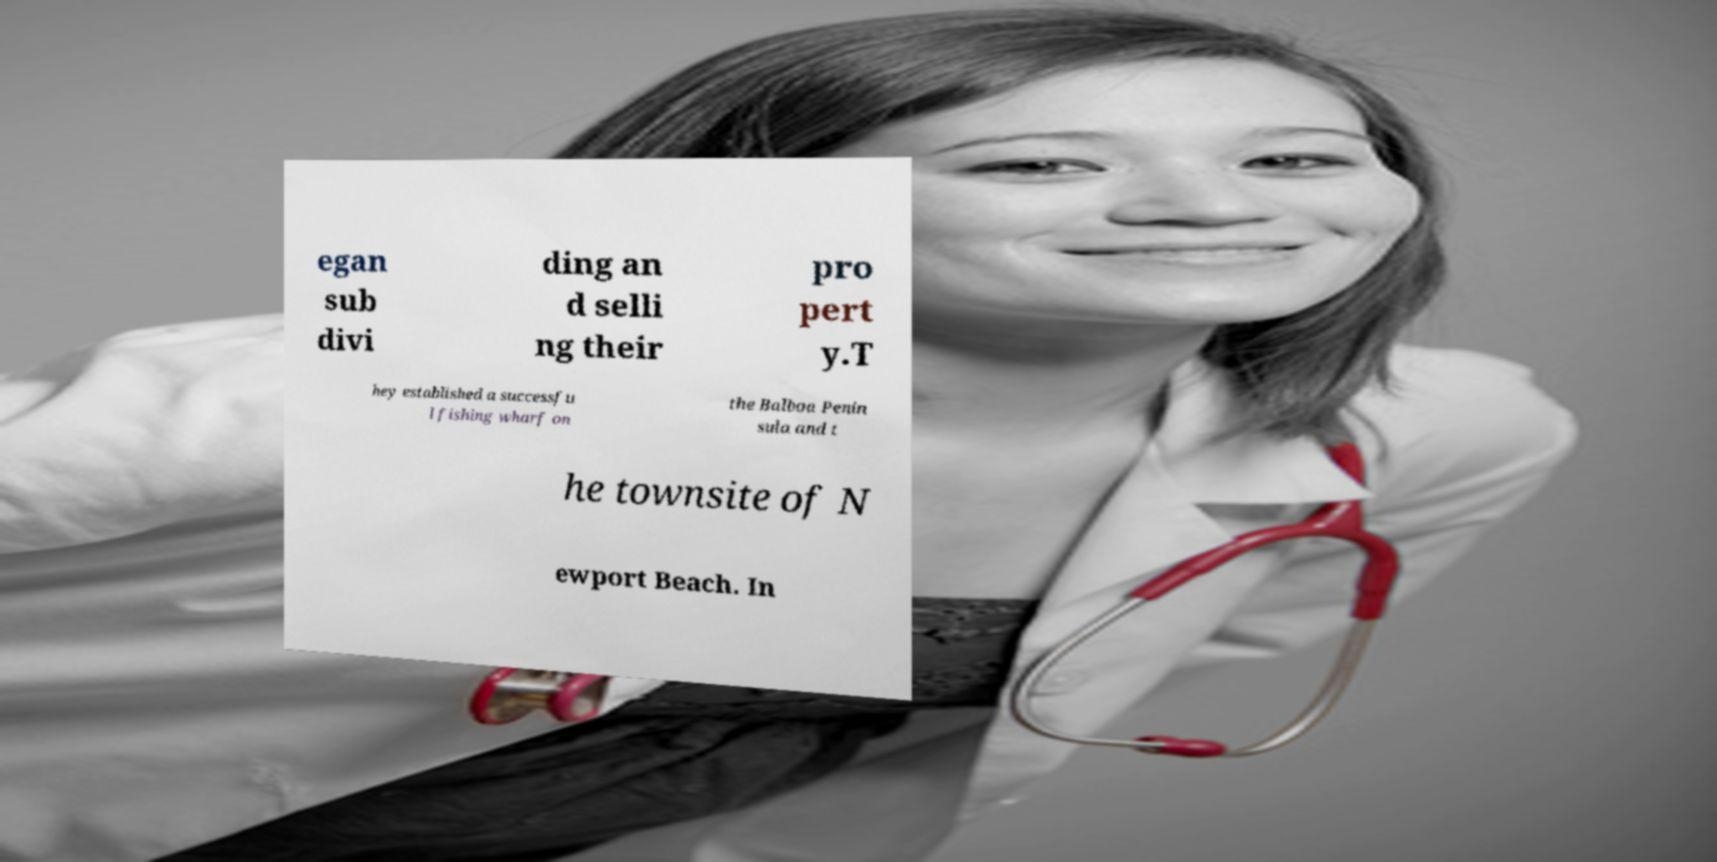What messages or text are displayed in this image? I need them in a readable, typed format. egan sub divi ding an d selli ng their pro pert y.T hey established a successfu l fishing wharf on the Balboa Penin sula and t he townsite of N ewport Beach. In 